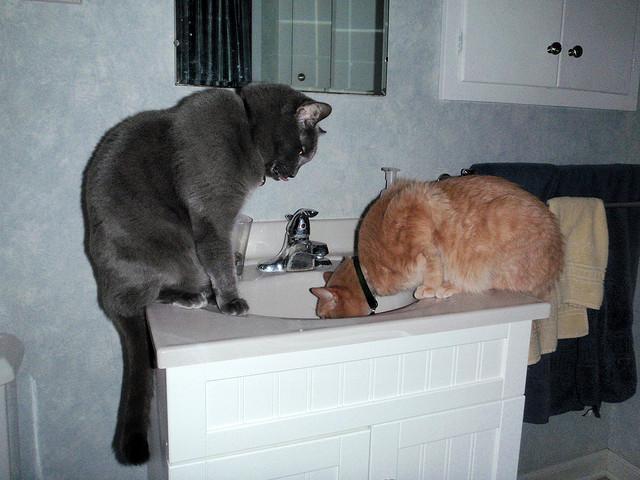How many cats are in the photo?
Give a very brief answer. 2. How many people are wearing a pink shirt?
Give a very brief answer. 0. 